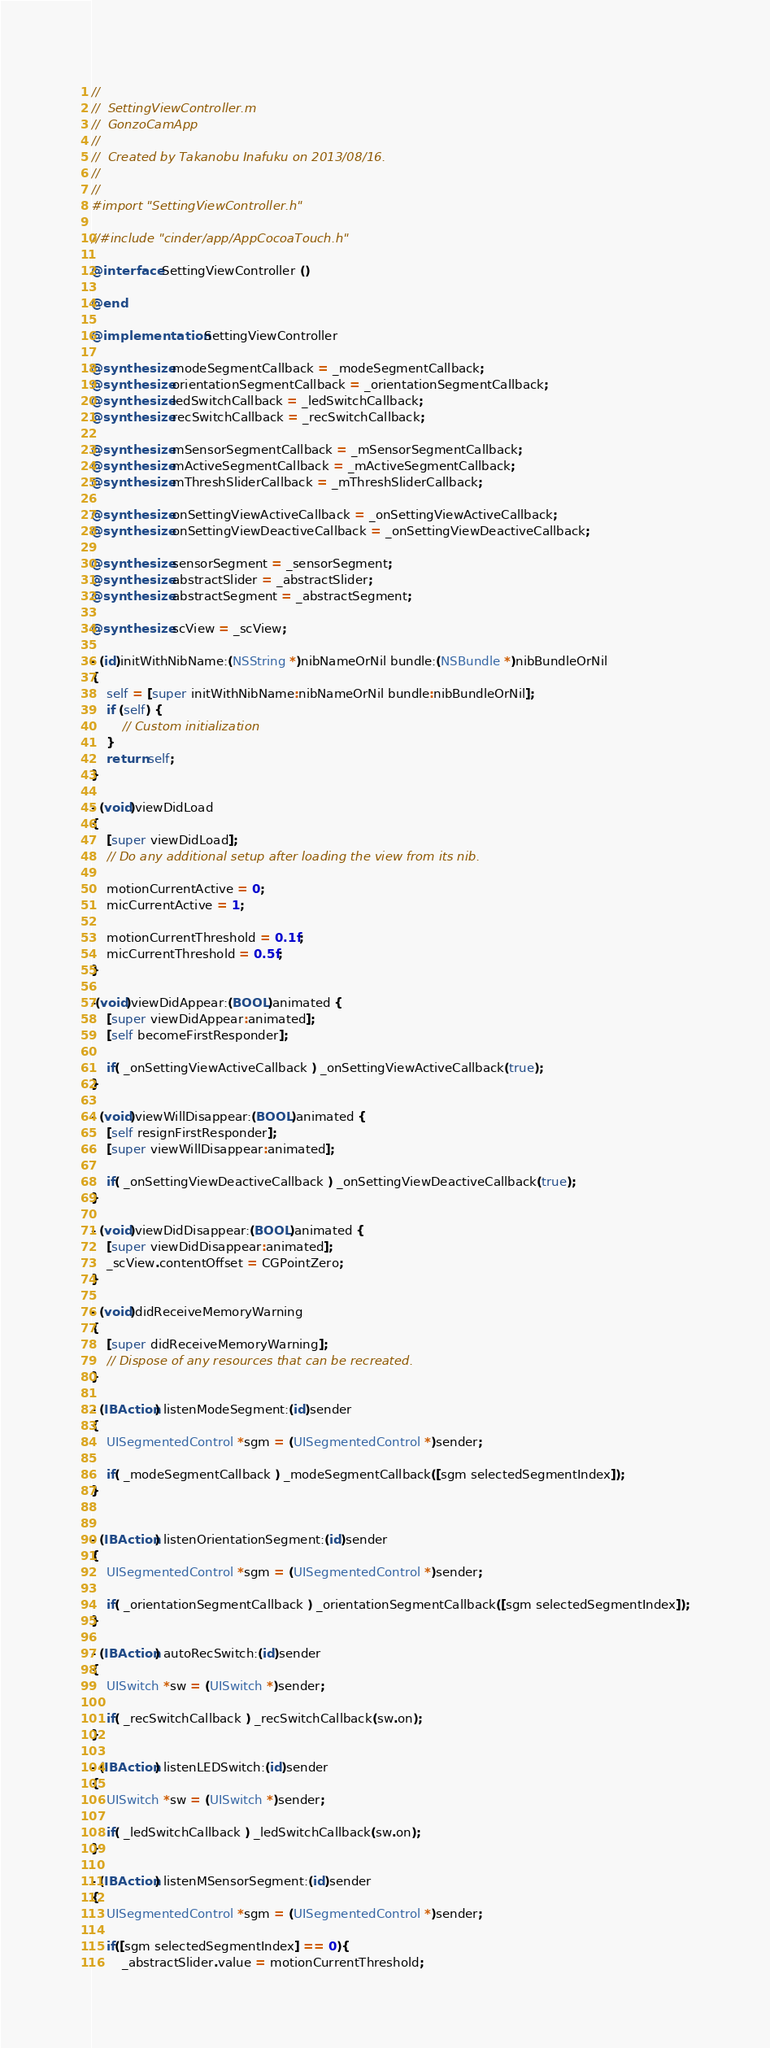Convert code to text. <code><loc_0><loc_0><loc_500><loc_500><_ObjectiveC_>//
//  SettingViewController.m
//  GonzoCamApp
//
//  Created by Takanobu Inafuku on 2013/08/16.
//
//
#import "SettingViewController.h"

//#include "cinder/app/AppCocoaTouch.h"

@interface SettingViewController ()

@end

@implementation SettingViewController

@synthesize modeSegmentCallback = _modeSegmentCallback;
@synthesize orientationSegmentCallback = _orientationSegmentCallback;
@synthesize ledSwitchCallback = _ledSwitchCallback;
@synthesize recSwitchCallback = _recSwitchCallback;

@synthesize mSensorSegmentCallback = _mSensorSegmentCallback;
@synthesize mActiveSegmentCallback = _mActiveSegmentCallback;
@synthesize mThreshSliderCallback = _mThreshSliderCallback;

@synthesize onSettingViewActiveCallback = _onSettingViewActiveCallback;
@synthesize onSettingViewDeactiveCallback = _onSettingViewDeactiveCallback;

@synthesize sensorSegment = _sensorSegment;
@synthesize abstractSlider = _abstractSlider;
@synthesize abstractSegment = _abstractSegment;

@synthesize scView = _scView;

- (id)initWithNibName:(NSString *)nibNameOrNil bundle:(NSBundle *)nibBundleOrNil
{
    self = [super initWithNibName:nibNameOrNil bundle:nibBundleOrNil];
    if (self) {
        // Custom initialization
    }
    return self;
}

- (void)viewDidLoad
{
    [super viewDidLoad];
    // Do any additional setup after loading the view from its nib.
    
    motionCurrentActive = 0;
    micCurrentActive = 1;
    
    motionCurrentThreshold = 0.1f;
    micCurrentThreshold = 0.5f;
}

-(void)viewDidAppear:(BOOL)animated {
    [super viewDidAppear:animated];
    [self becomeFirstResponder];
    
    if( _onSettingViewActiveCallback ) _onSettingViewActiveCallback(true);
}

- (void)viewWillDisappear:(BOOL)animated {
    [self resignFirstResponder];
    [super viewWillDisappear:animated];

    if( _onSettingViewDeactiveCallback ) _onSettingViewDeactiveCallback(true);
}

- (void)viewDidDisappear:(BOOL)animated {
    [super viewDidDisappear:animated];
    _scView.contentOffset = CGPointZero;
}

- (void)didReceiveMemoryWarning
{
    [super didReceiveMemoryWarning];
    // Dispose of any resources that can be recreated.
}

- (IBAction) listenModeSegment:(id)sender
{
    UISegmentedControl *sgm = (UISegmentedControl *)sender;
    
    if( _modeSegmentCallback ) _modeSegmentCallback([sgm selectedSegmentIndex]);
}


- (IBAction) listenOrientationSegment:(id)sender
{
    UISegmentedControl *sgm = (UISegmentedControl *)sender;
    
    if( _orientationSegmentCallback ) _orientationSegmentCallback([sgm selectedSegmentIndex]);
}

- (IBAction) autoRecSwitch:(id)sender
{
    UISwitch *sw = (UISwitch *)sender;
    
    if( _recSwitchCallback ) _recSwitchCallback(sw.on);
}

- (IBAction) listenLEDSwitch:(id)sender
{
    UISwitch *sw = (UISwitch *)sender;
    
    if( _ledSwitchCallback ) _ledSwitchCallback(sw.on);
}

- (IBAction) listenMSensorSegment:(id)sender
{
    UISegmentedControl *sgm = (UISegmentedControl *)sender;
    
    if([sgm selectedSegmentIndex] == 0){
        _abstractSlider.value = motionCurrentThreshold;</code> 